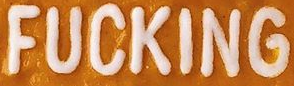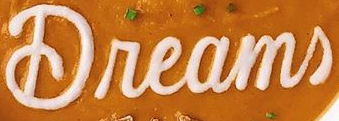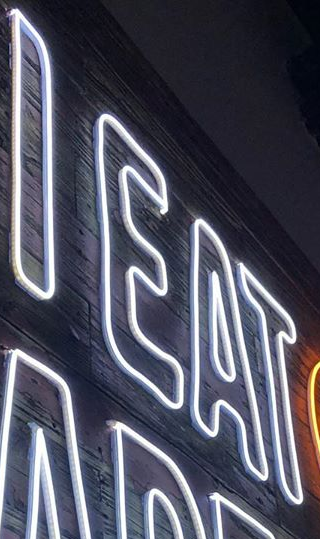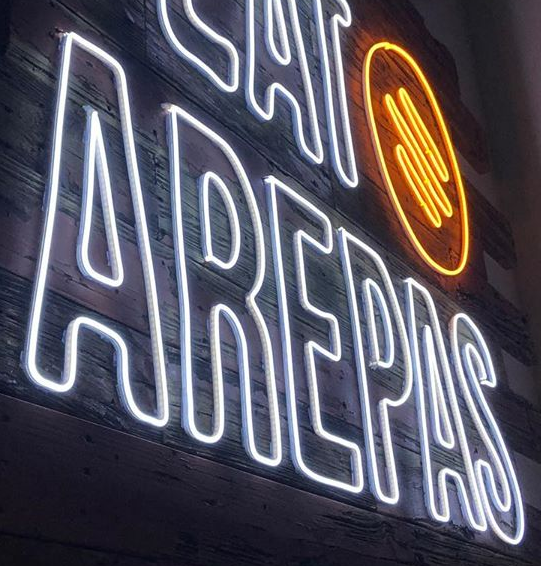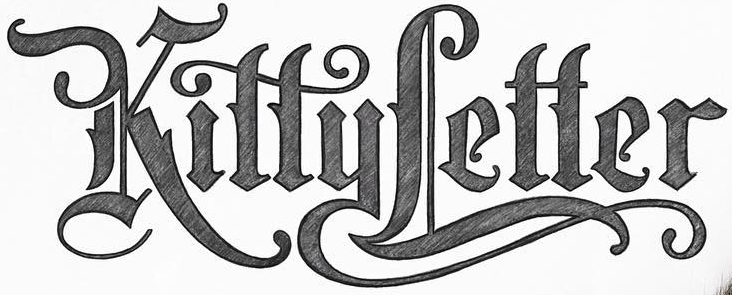What words can you see in these images in sequence, separated by a semicolon? FUCKING; Dreams; IEAT; AREPAS; KittyLetter 